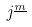Convert formula to latex. <formula><loc_0><loc_0><loc_500><loc_500>j ^ { \underline { m } }</formula> 